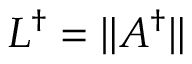<formula> <loc_0><loc_0><loc_500><loc_500>L ^ { \dagger } = \| A ^ { \dagger } \|</formula> 